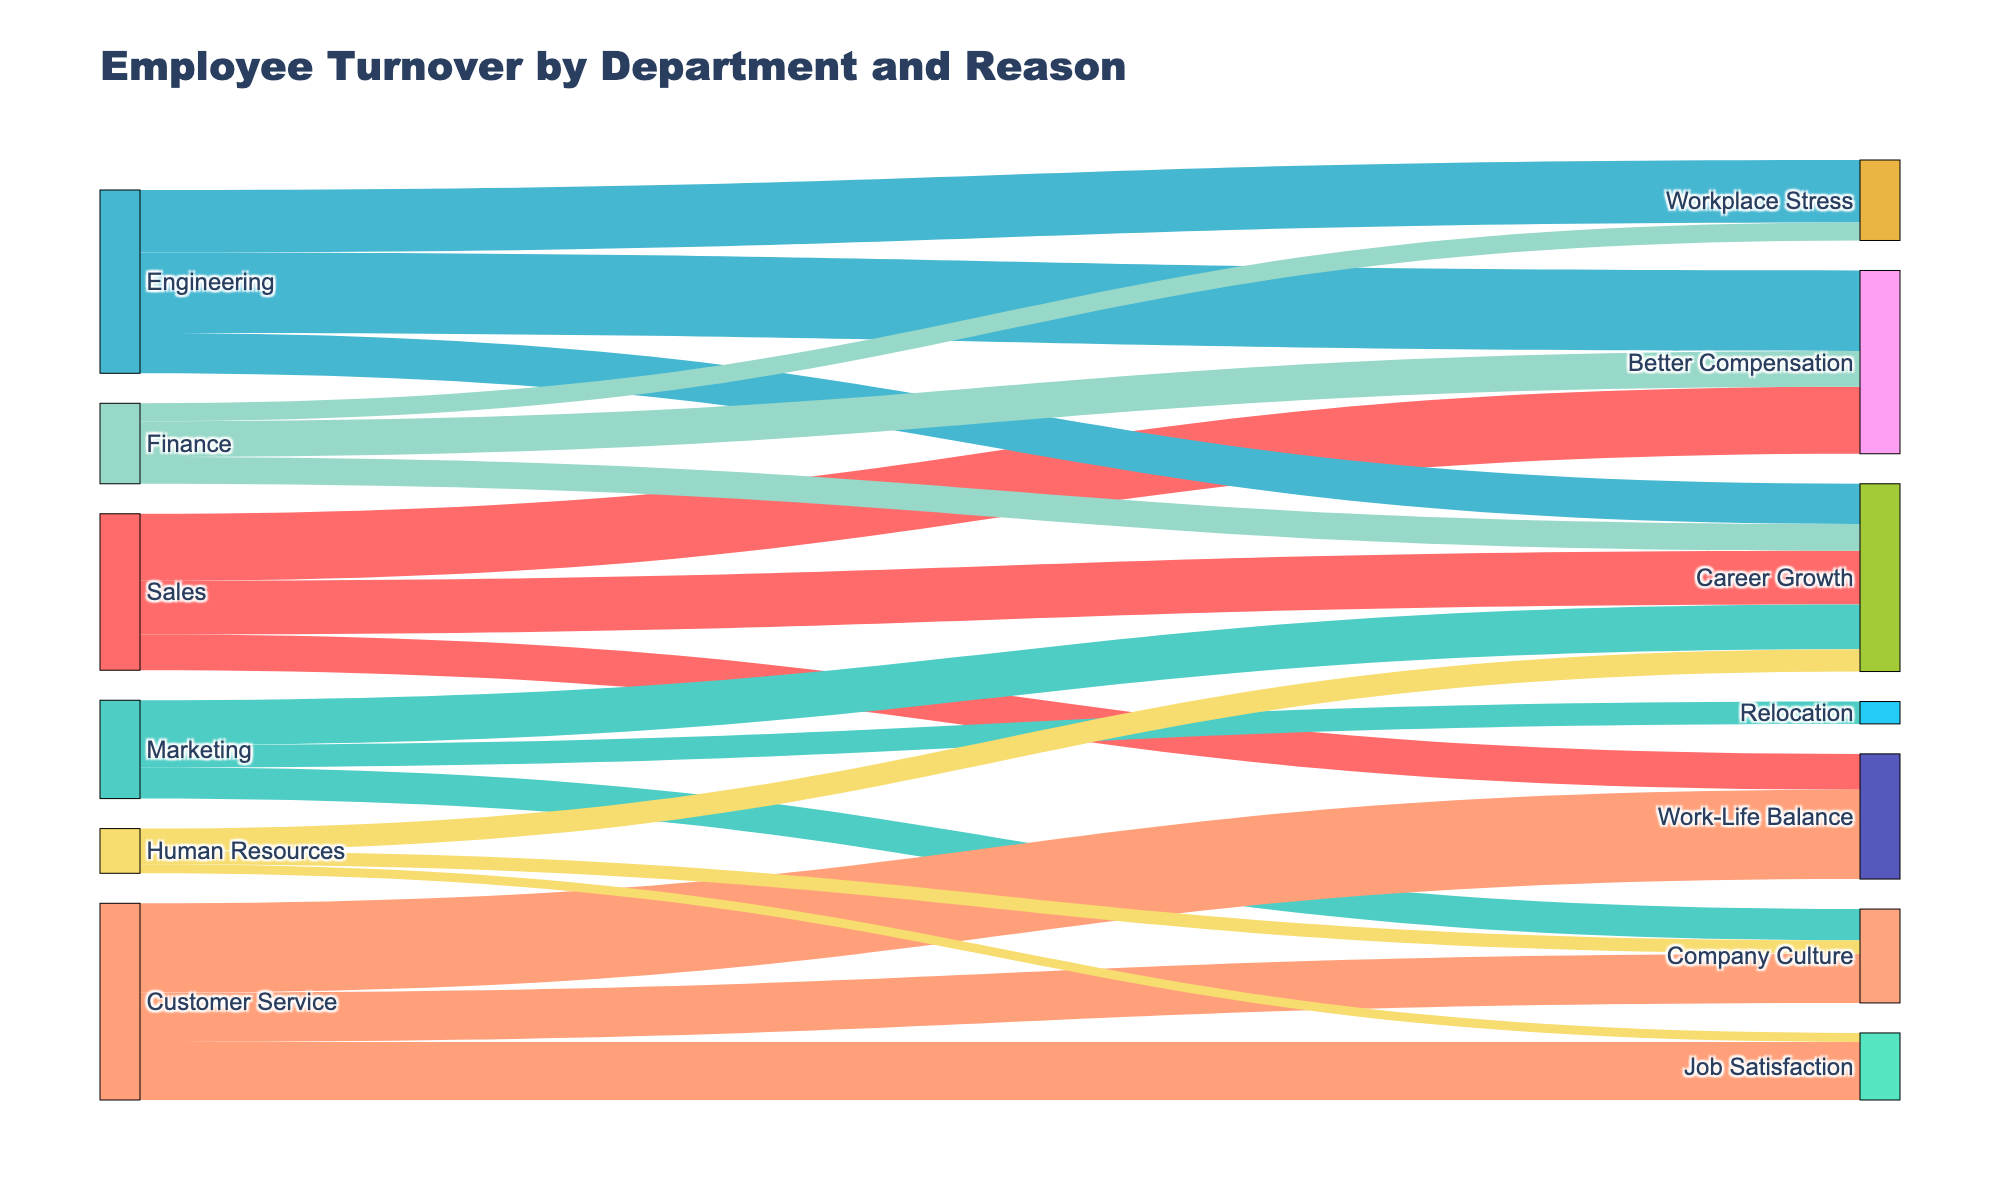What's the title of the Sankey diagram? The title is displayed at the top of the figure, indicating the main topic of the visualization.
Answer: Employee Turnover by Department and Reason Which department has the highest number of employees leaving due to Better Compensation? Look at the links connected to the "Better Compensation" node; identify the one with the largest value coming from different departments.
Answer: Engineering How many employees left the Marketing department due to Career Growth? Locate the node for "Marketing" and follow the link to "Career Growth," then check the value associated with this link.
Answer: 10 Compare the number of employees leaving Sales due to Work-Life Balance with those leaving Customer Service for the same reason. Which is higher? Look at the "Work-Life Balance" node and compare the values of the links coming from "Sales" and "Customer Service."
Answer: Customer Service Summing up all reasons, what's the total number of employees leaving the Engineering department? Add up the number of employees leaving Engineering due to Better Compensation, Workplace Stress, and Career Growth.
Answer: 41 How can you compare the reasons for leaving between the Finance and Human Resources departments? Identify and sum the numbers associated with each reason for both departments, then compare the totals for each category.
Answer: Finance has higher numbers overall What is the most common reason for leaving across all departments? Look for the reason with the highest cumulative number across all departments.
Answer: Better Compensation Determine the department with the lowest number of employees leaving due to Company Culture. Identify which department has the smallest value linked to the "Company Culture" node.
Answer: Human Resources How many unique reasons for leaving are there in the diagram? Count the number of unique reasons displayed in the Sankey diagram as nodes.
Answer: 6 What is the combined total of employees leaving the Sales and Marketing departments due to Career Growth? Add the number of employees leaving Sales (12) and Marketing (10) due to Career Growth.
Answer: 22 